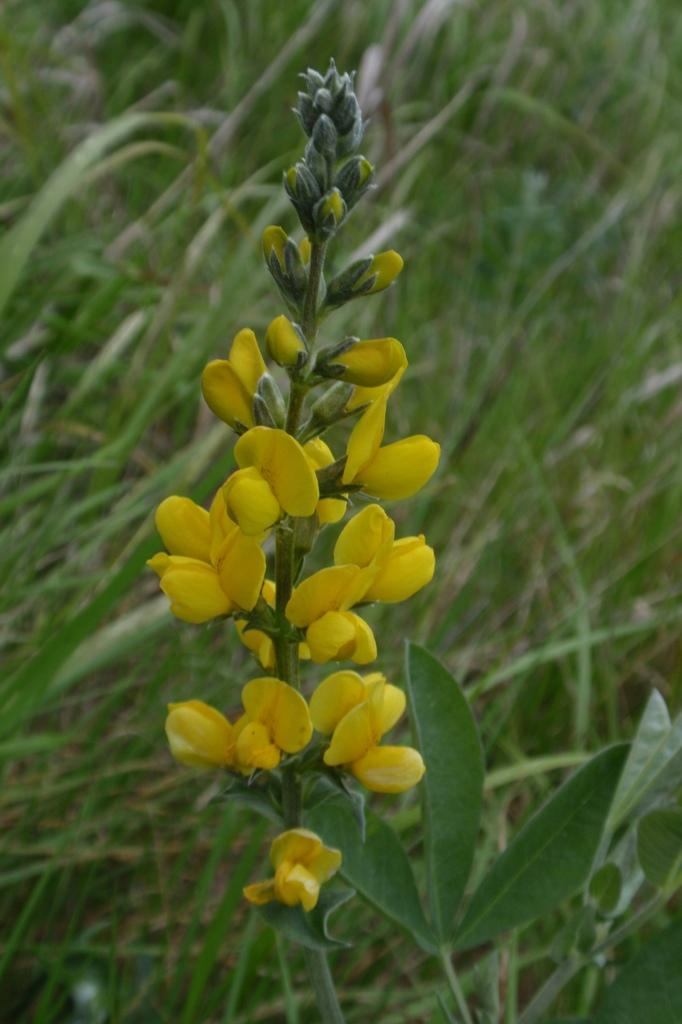What type of flowers can be seen on the plant in the image? There are yellow flowers on a plant in the image. How is the background of the plant depicted in the image? The background of the plant is blurred in the image. What type of sweater is the man wearing in the image? There is no man or sweater present in the image; it only features yellow flowers on a plant with a blurred background. 